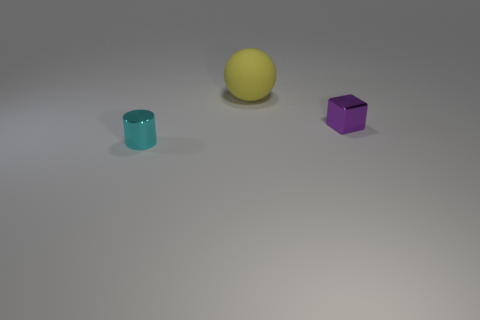Does the thing behind the purple object have the same material as the thing that is right of the large matte sphere?
Offer a very short reply. No. There is a small shiny thing to the right of the sphere; are there any tiny cubes to the left of it?
Give a very brief answer. No. The tiny thing that is made of the same material as the cyan cylinder is what color?
Your answer should be very brief. Purple. Are there more small yellow matte objects than tiny metallic blocks?
Your answer should be very brief. No. How many things are either tiny shiny things on the right side of the rubber thing or tiny red metallic things?
Your response must be concise. 1. Are there any blue matte cylinders that have the same size as the cyan shiny object?
Your answer should be very brief. No. Is the number of blocks less than the number of small brown matte spheres?
Your answer should be very brief. No. What number of blocks are either tiny purple metal objects or cyan shiny things?
Make the answer very short. 1. How many other spheres are the same color as the big matte sphere?
Keep it short and to the point. 0. There is a thing that is in front of the yellow rubber thing and to the right of the tiny cyan shiny cylinder; what is its size?
Your answer should be compact. Small. 